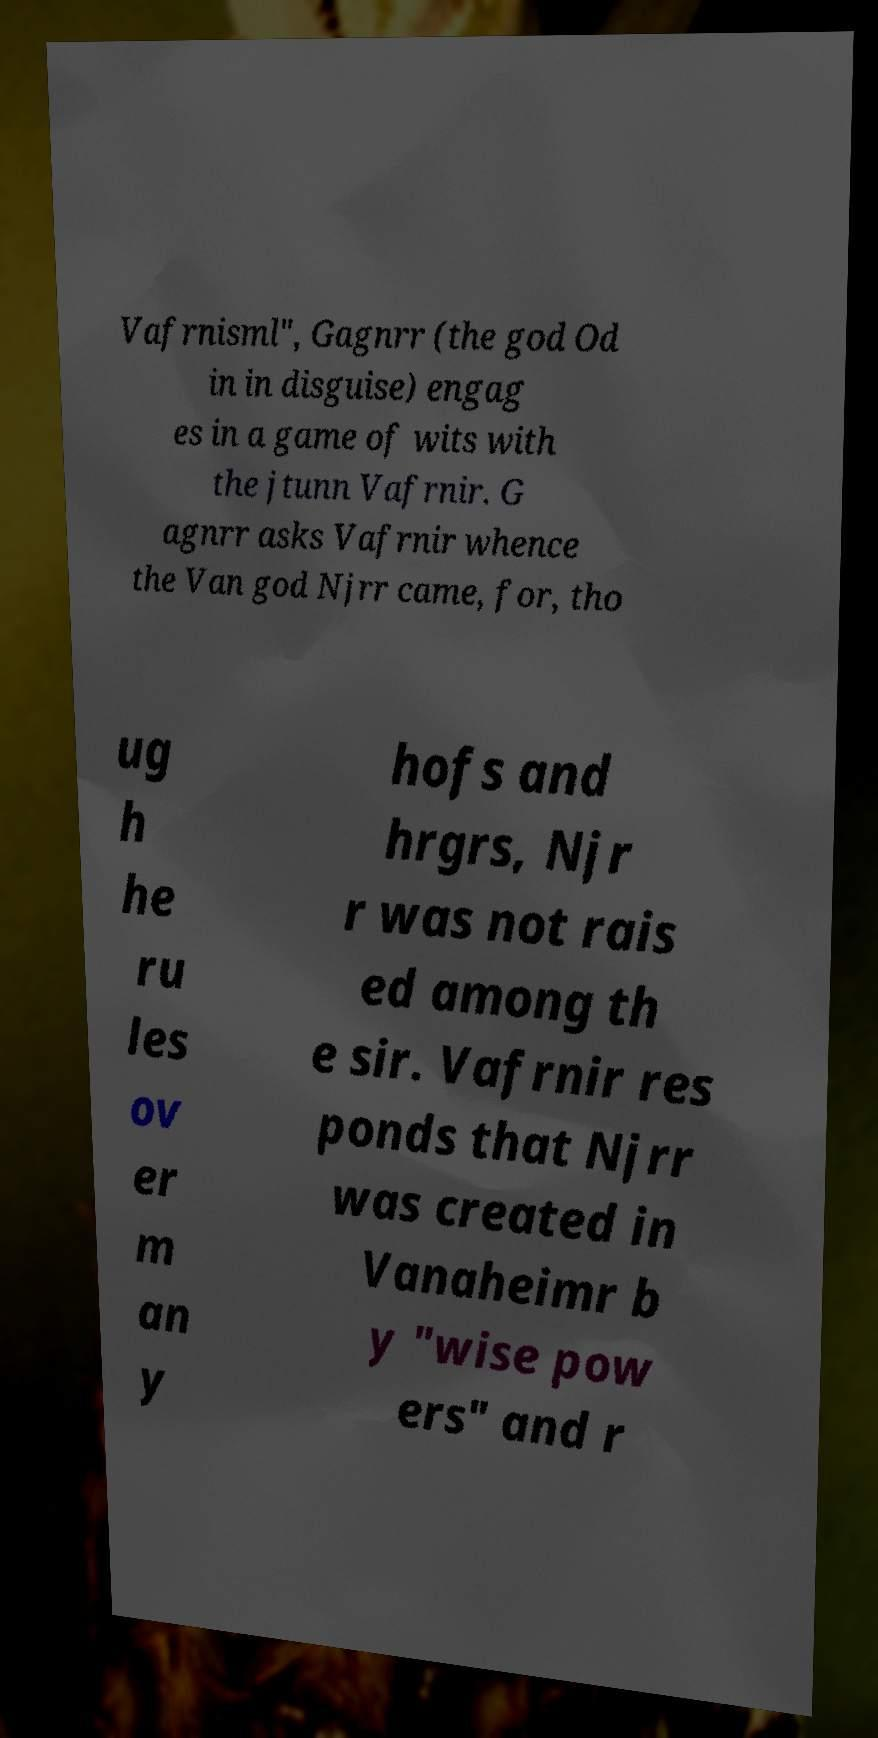Please read and relay the text visible in this image. What does it say? Vafrnisml", Gagnrr (the god Od in in disguise) engag es in a game of wits with the jtunn Vafrnir. G agnrr asks Vafrnir whence the Van god Njrr came, for, tho ug h he ru les ov er m an y hofs and hrgrs, Njr r was not rais ed among th e sir. Vafrnir res ponds that Njrr was created in Vanaheimr b y "wise pow ers" and r 